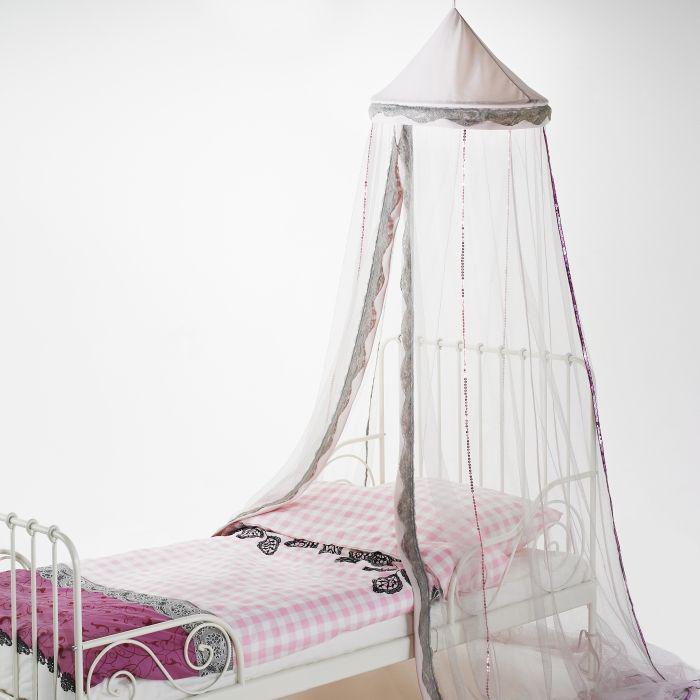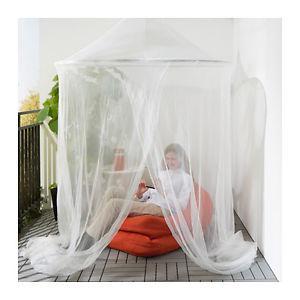The first image is the image on the left, the second image is the image on the right. Given the left and right images, does the statement "All of the curtains are draped above regular beds." hold true? Answer yes or no. No. The first image is the image on the left, the second image is the image on the right. Examine the images to the left and right. Is the description "There are two beds in total." accurate? Answer yes or no. No. 